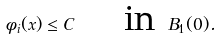Convert formula to latex. <formula><loc_0><loc_0><loc_500><loc_500>\phi _ { i } ( x ) \leq C \quad \text { in } B _ { 1 } ( 0 ) .</formula> 